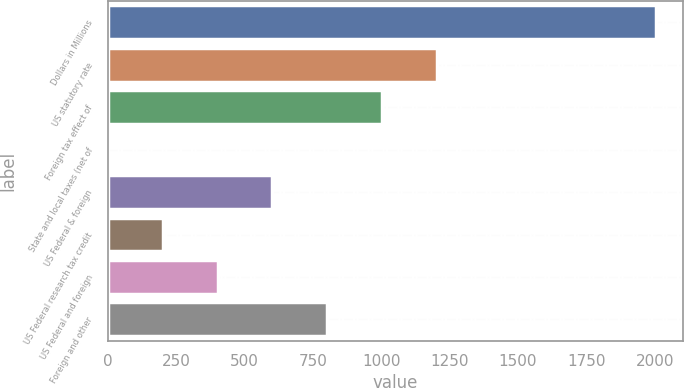Convert chart to OTSL. <chart><loc_0><loc_0><loc_500><loc_500><bar_chart><fcel>Dollars in Millions<fcel>US statutory rate<fcel>Foreign tax effect of<fcel>State and local taxes (net of<fcel>US Federal & foreign<fcel>US Federal research tax credit<fcel>US Federal and foreign<fcel>Foreign and other<nl><fcel>2004<fcel>1202.52<fcel>1002.15<fcel>0.3<fcel>601.41<fcel>200.67<fcel>401.04<fcel>801.78<nl></chart> 